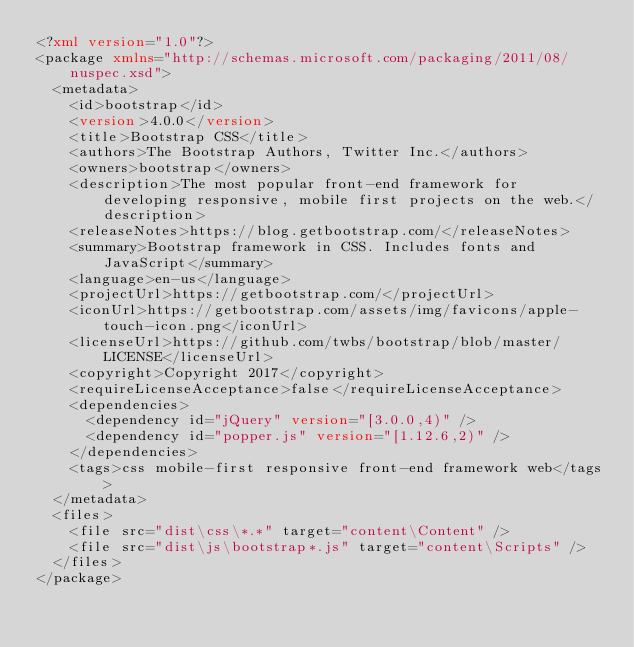<code> <loc_0><loc_0><loc_500><loc_500><_XML_><?xml version="1.0"?>
<package xmlns="http://schemas.microsoft.com/packaging/2011/08/nuspec.xsd">
  <metadata>
    <id>bootstrap</id>
    <version>4.0.0</version>
    <title>Bootstrap CSS</title>
    <authors>The Bootstrap Authors, Twitter Inc.</authors>
    <owners>bootstrap</owners>
    <description>The most popular front-end framework for developing responsive, mobile first projects on the web.</description>
    <releaseNotes>https://blog.getbootstrap.com/</releaseNotes>
    <summary>Bootstrap framework in CSS. Includes fonts and JavaScript</summary>
    <language>en-us</language>
    <projectUrl>https://getbootstrap.com/</projectUrl>
    <iconUrl>https://getbootstrap.com/assets/img/favicons/apple-touch-icon.png</iconUrl>
    <licenseUrl>https://github.com/twbs/bootstrap/blob/master/LICENSE</licenseUrl>
    <copyright>Copyright 2017</copyright>
    <requireLicenseAcceptance>false</requireLicenseAcceptance>
    <dependencies>
      <dependency id="jQuery" version="[3.0.0,4)" />
      <dependency id="popper.js" version="[1.12.6,2)" />
    </dependencies>
    <tags>css mobile-first responsive front-end framework web</tags>
  </metadata>
  <files>
    <file src="dist\css\*.*" target="content\Content" />
    <file src="dist\js\bootstrap*.js" target="content\Scripts" />
  </files>
</package>
</code> 